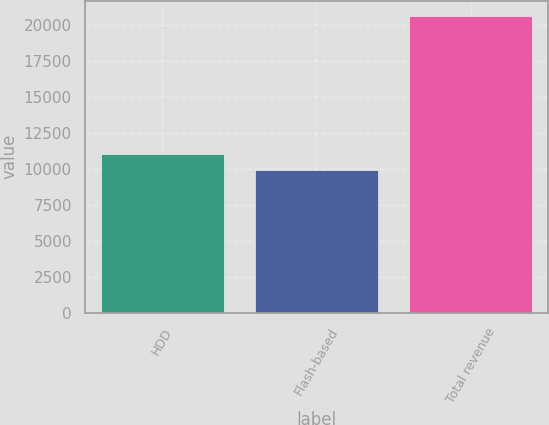Convert chart. <chart><loc_0><loc_0><loc_500><loc_500><bar_chart><fcel>HDD<fcel>Flash-based<fcel>Total revenue<nl><fcel>11018.8<fcel>9949<fcel>20647<nl></chart> 